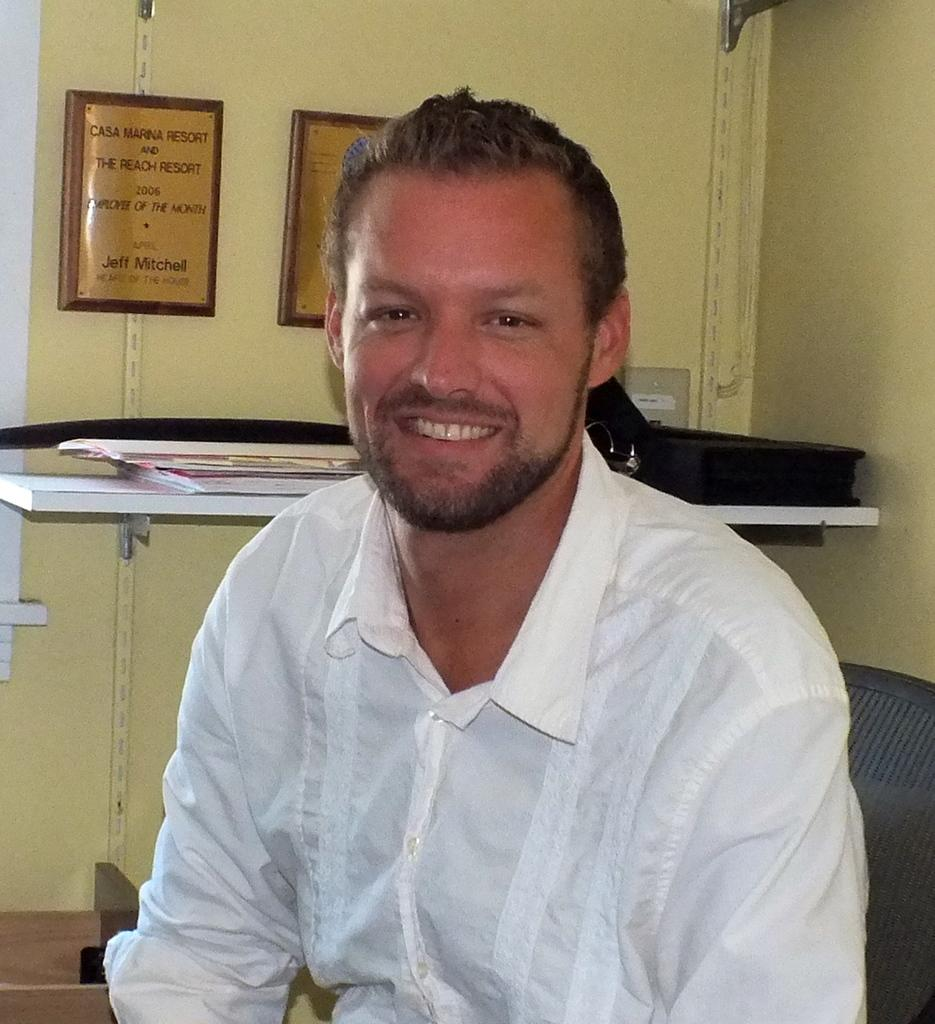What is the person in the image doing? There is a person sitting on a chair in the image. What can be seen on the shelf in the image? There are objects on a shelf in the image. What is on the wall in the image? There are frames with text on the wall in the image. Where is the map located in the image? There is no map present in the image. What type of plot is being discussed in the image? There is no plot or discussion about a plot in the image. 